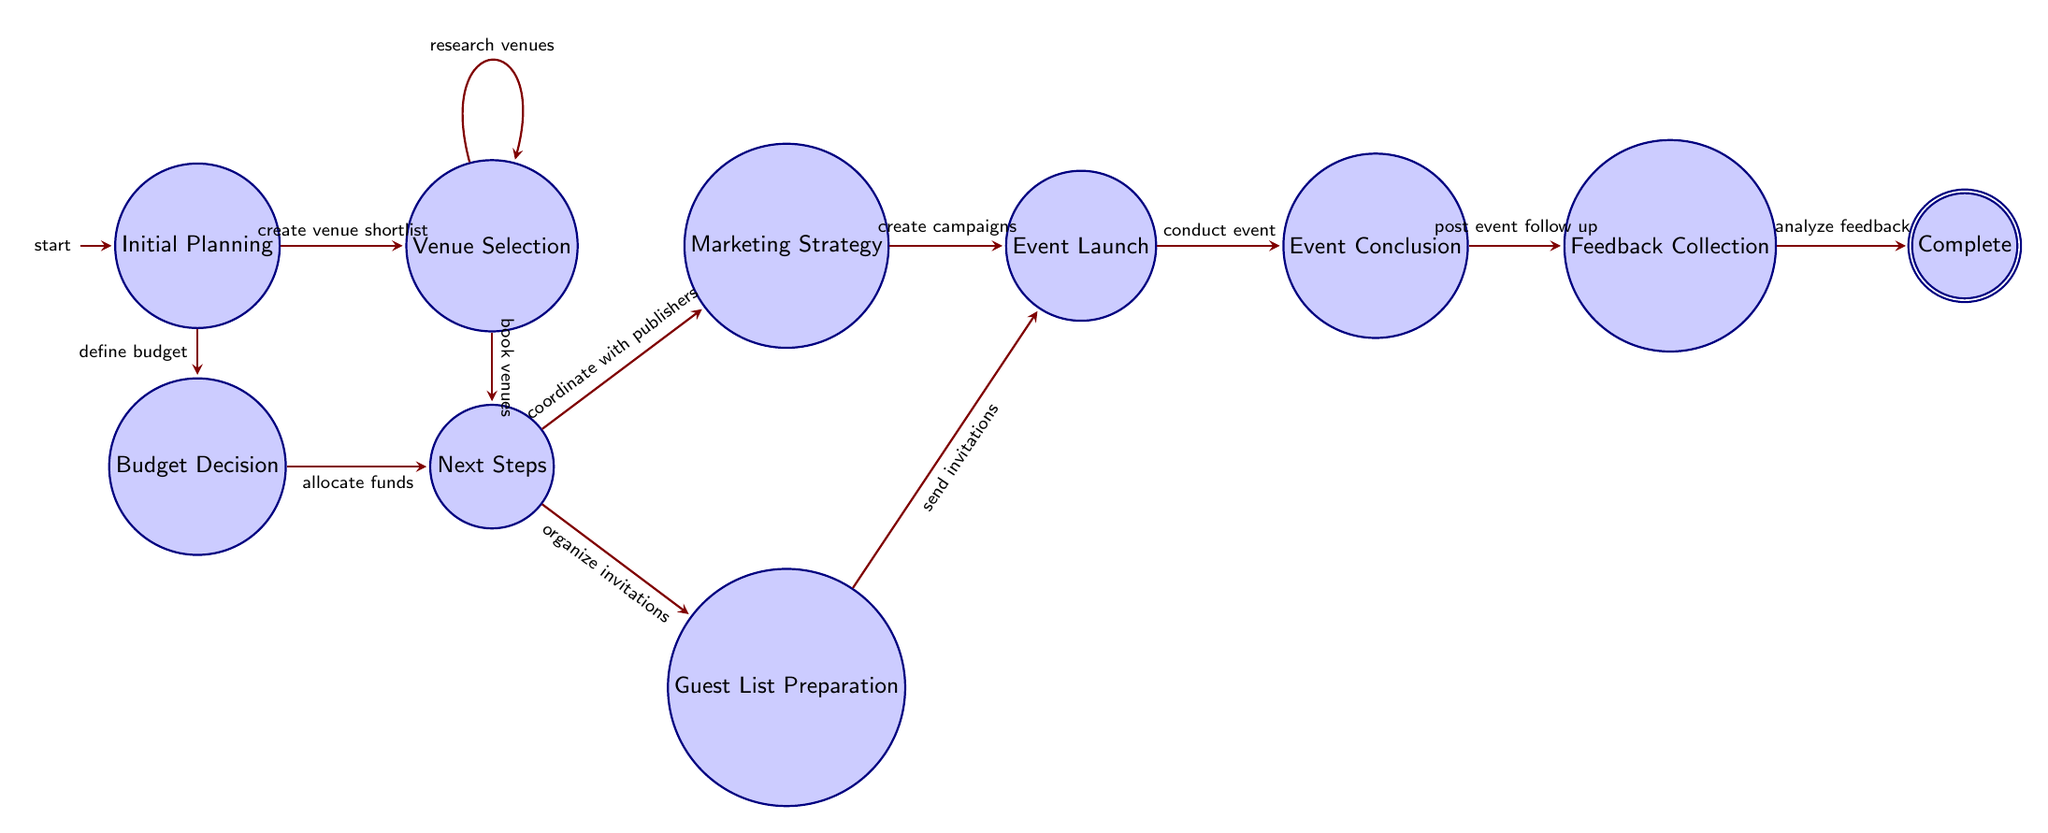What is the first state in the diagram? The first state in the diagram is "Initial Planning," which is indicated as the initial state.
Answer: Initial Planning How many total states are present in the diagram? The diagram includes a total of nine states, which can be counted directly from the nodes represented.
Answer: Nine What event leads from the Venue Selection state to the Next Steps state? The transition from Venue Selection to Next Steps is based on the event "book venues." This is noted on the edge connecting the two states.
Answer: Book venues Which state follows after Budget Decision? The state that follows Budget Decision is called "Next Steps," as indicated by the directed edge from Budget Decision to Next Steps.
Answer: Next Steps What two actions can be taken from the Next Steps state? From Next Steps, two actions can be taken: "coordinate with publishers" leading to Marketing Strategy and "organize invitations" leading to Guest List Preparation.
Answer: Coordinate with publishers, organize invitations What is the final state in the diagram? The final state in the diagram is "Complete," which signifies the end of the process. It is marked as the accepting state.
Answer: Complete What actions precede the Event Launch state? The actions that precede the Event Launch state include "create campaigns" from the Marketing Strategy state and "send invitations" from the Guest List Preparation state.
Answer: Create campaigns, send invitations How is feedback collected after the event? Feedback is collected in the Feedback Collection state, which follows the Event Conclusion state, where post-event follow-up occurs.
Answer: Post event follow up What event finalizes the budget in the Budget Decision state? The event that finalizes the budget in the Budget Decision state is "allocate funds," which leads to the Next Steps state.
Answer: Allocate funds 